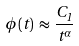<formula> <loc_0><loc_0><loc_500><loc_500>\phi ( t ) \, \approx \, \frac { C _ { 1 } } { t ^ { \alpha } } \,</formula> 